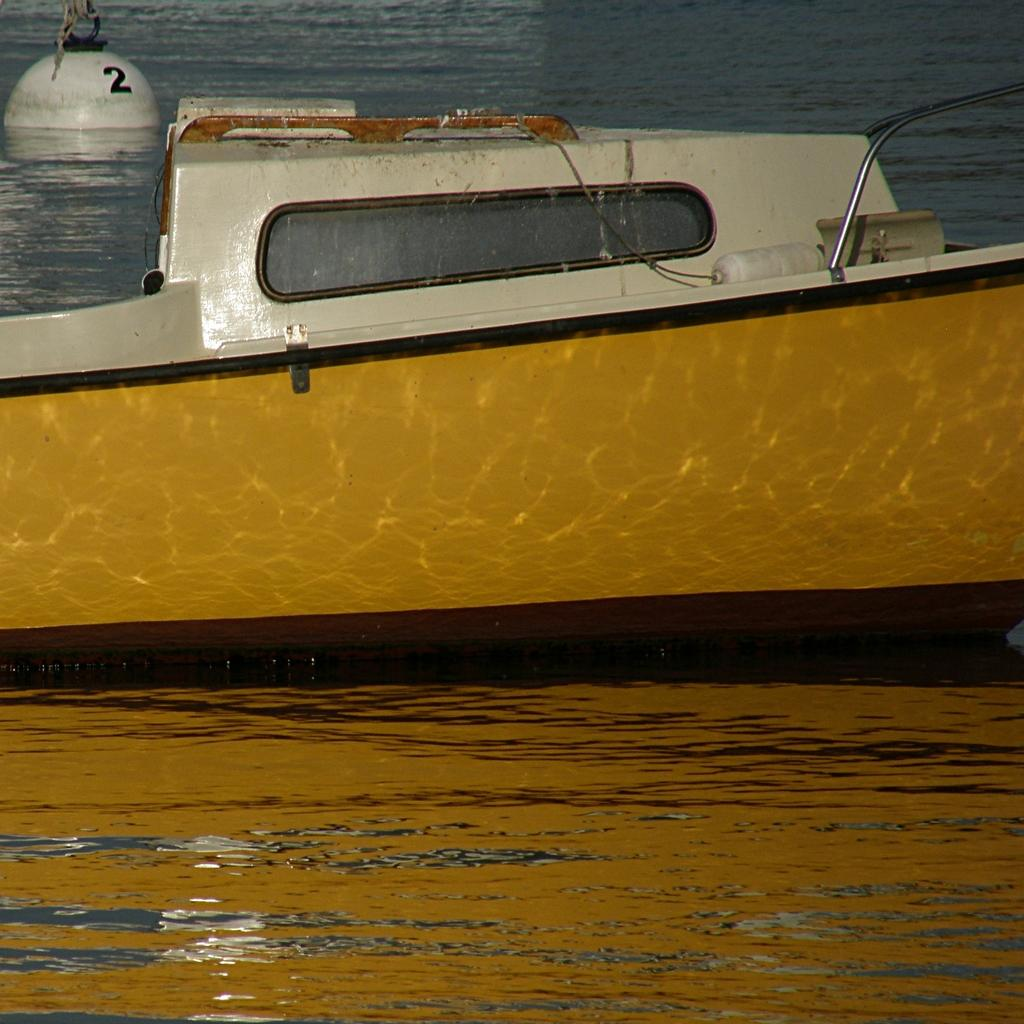What is the main subject of the image? The main subject of the image is a boat. Can you describe the boat's position in relation to the water? The boat is above the water in the image. What else can be seen in the background of the image? There is an object visible in the background of the image. What type of punishment is being administered to the boat in the image? There is no punishment being administered to the boat in the image; it is simply a boat above the water. How much pain is the boat experiencing in the image? Boats do not experience pain, so this question is not applicable to the image. 